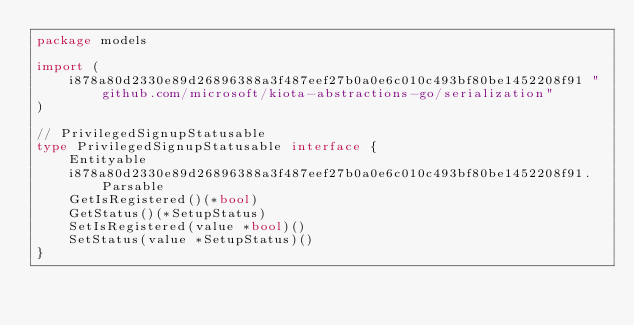Convert code to text. <code><loc_0><loc_0><loc_500><loc_500><_Go_>package models

import (
    i878a80d2330e89d26896388a3f487eef27b0a0e6c010c493bf80be1452208f91 "github.com/microsoft/kiota-abstractions-go/serialization"
)

// PrivilegedSignupStatusable 
type PrivilegedSignupStatusable interface {
    Entityable
    i878a80d2330e89d26896388a3f487eef27b0a0e6c010c493bf80be1452208f91.Parsable
    GetIsRegistered()(*bool)
    GetStatus()(*SetupStatus)
    SetIsRegistered(value *bool)()
    SetStatus(value *SetupStatus)()
}
</code> 